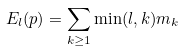Convert formula to latex. <formula><loc_0><loc_0><loc_500><loc_500>E _ { l } ( p ) = \sum _ { k \geq 1 } \min ( l , k ) m _ { k }</formula> 